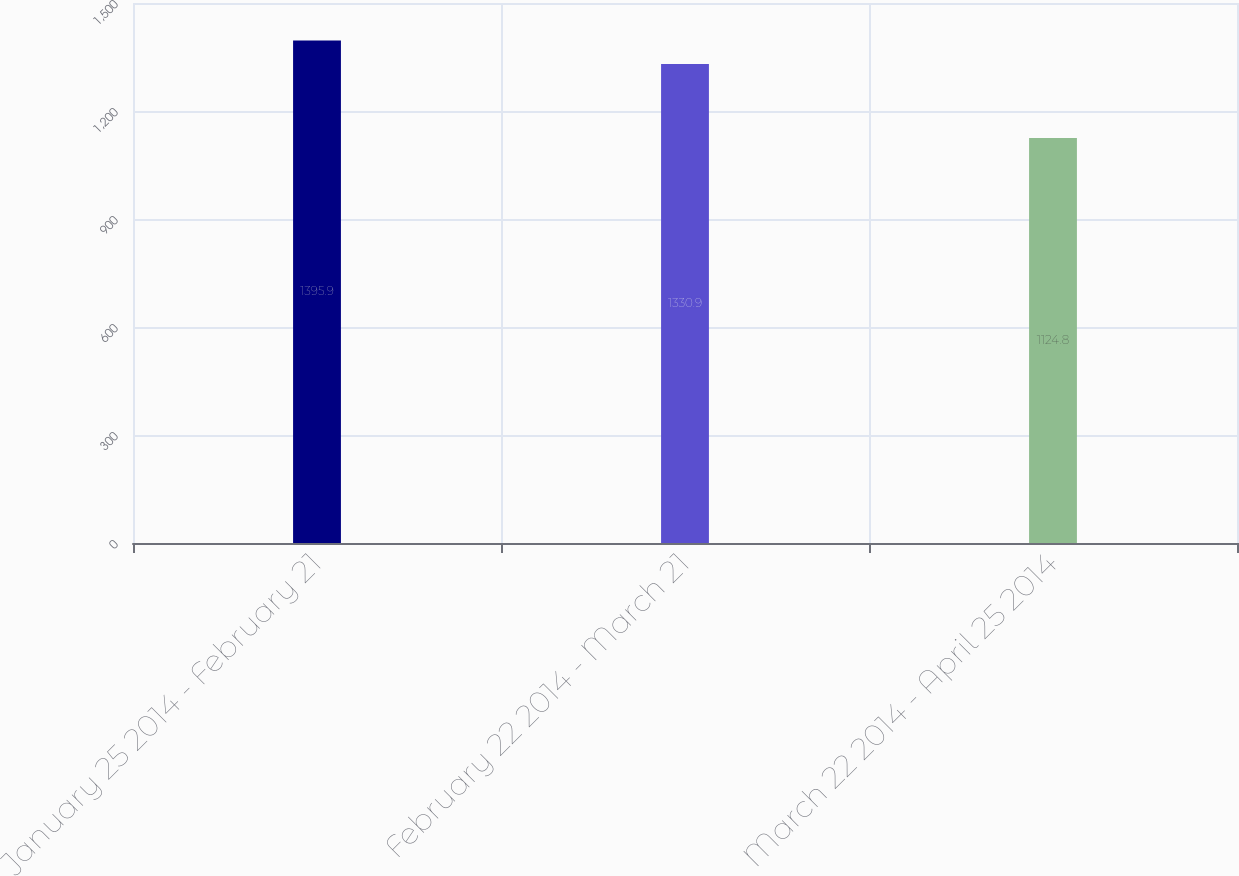<chart> <loc_0><loc_0><loc_500><loc_500><bar_chart><fcel>January 25 2014 - February 21<fcel>February 22 2014 - March 21<fcel>March 22 2014 - April 25 2014<nl><fcel>1395.9<fcel>1330.9<fcel>1124.8<nl></chart> 